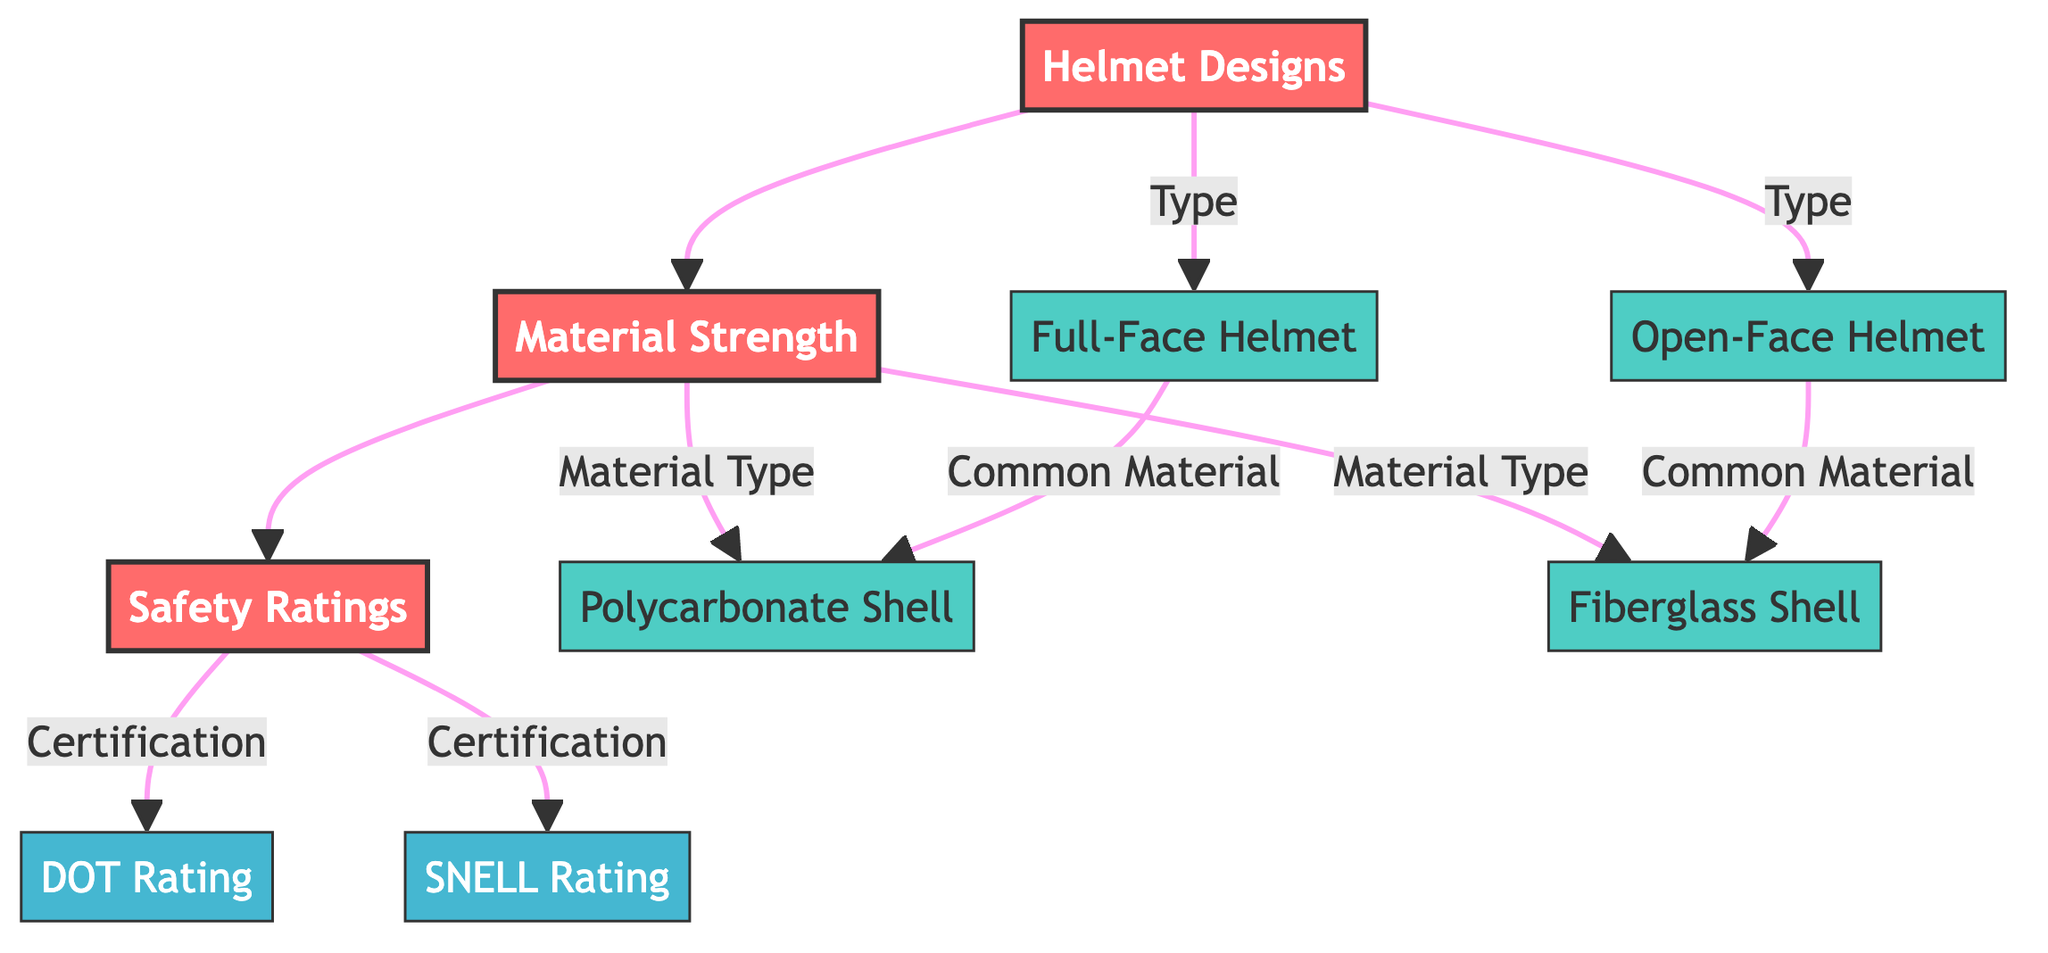What is the main node in this diagram? The main nodes in this diagram are Helmet Designs, Material Strength, and Safety Ratings, as they are highlighted and serve as the primary categories related to protective gear.
Answer: Helmet Designs, Material Strength, Safety Ratings How many types of helmet designs are listed? The diagram shows two types of helmet designs: Full-Face Helmet and Open-Face Helmet, making it easy to identify the main categories under helmet designs.
Answer: 2 What materials are associated with material strength in the diagram? The materials linked with Material Strength are Polycarbonate Shell and Fiberglass Shell, according to the relationships defined in the flowchart.
Answer: Polycarbonate Shell, Fiberglass Shell What certification types are mentioned in Safety Ratings? The certifications listed under Safety Ratings are DOT Rating and SNELL Rating, which indicate the standards against which helmets are tested for safety.
Answer: DOT Rating, SNELL Rating Which helmet design commonly uses Polycarbonate Shell as a material? The Full-Face Helmet design is associated with the Polycarbonate Shell, indicating a specific combination shown in the flowchart.
Answer: Full-Face Helmet How are Helmet Designs, Material Strength, and Safety Ratings connected in this diagram? The connection is shown through arrows: Helmet Designs leads to Material Strength, which in turn leads to Safety Ratings, indicating a flow from types of helmets to their material properties and safety certifications.
Answer: Through arrows (Helmet Designs → Material Strength → Safety Ratings) Which node represents the material type related to Open-Face Helmet? The material type associated with Open-Face Helmet is Fiberglass Shell, as shown in the diagram under the common materials listed for different helmet designs.
Answer: Fiberglass Shell 